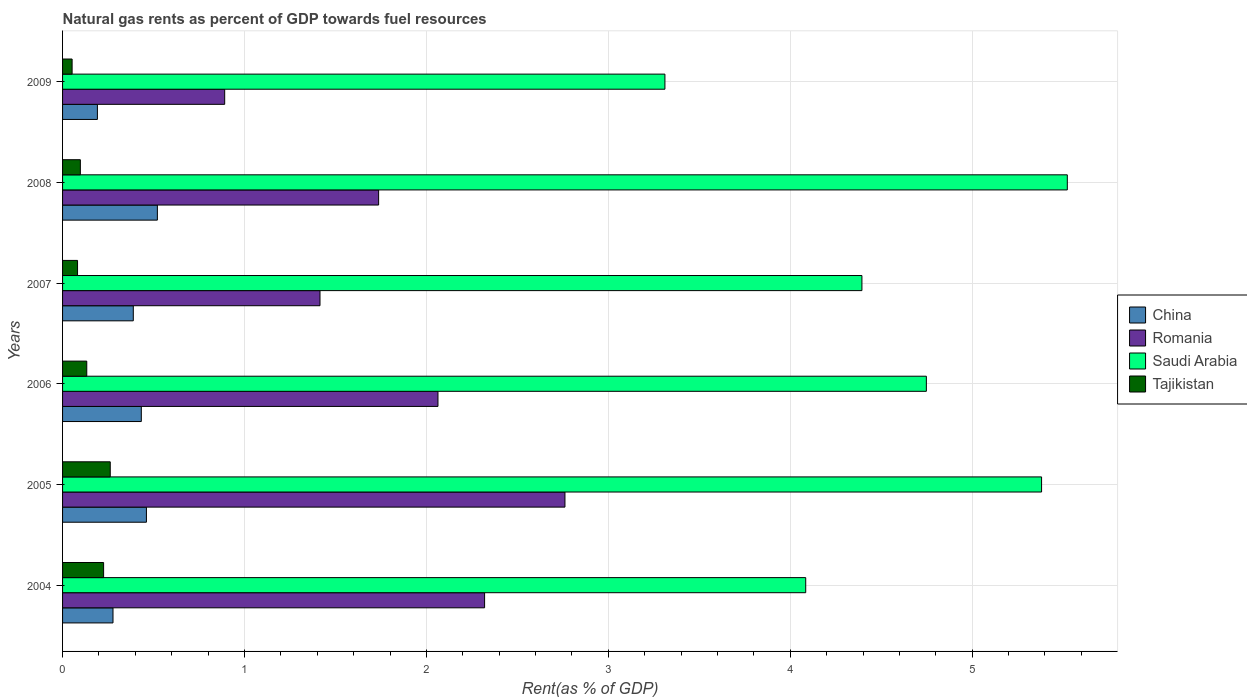How many groups of bars are there?
Make the answer very short. 6. Are the number of bars per tick equal to the number of legend labels?
Offer a very short reply. Yes. Are the number of bars on each tick of the Y-axis equal?
Your response must be concise. Yes. How many bars are there on the 3rd tick from the bottom?
Give a very brief answer. 4. In how many cases, is the number of bars for a given year not equal to the number of legend labels?
Provide a succinct answer. 0. What is the matural gas rent in Tajikistan in 2007?
Make the answer very short. 0.08. Across all years, what is the maximum matural gas rent in China?
Your answer should be compact. 0.52. Across all years, what is the minimum matural gas rent in Saudi Arabia?
Make the answer very short. 3.31. In which year was the matural gas rent in Tajikistan maximum?
Provide a succinct answer. 2005. What is the total matural gas rent in China in the graph?
Offer a terse response. 2.27. What is the difference between the matural gas rent in Saudi Arabia in 2005 and that in 2009?
Ensure brevity in your answer.  2.07. What is the difference between the matural gas rent in Romania in 2006 and the matural gas rent in Tajikistan in 2007?
Provide a short and direct response. 1.98. What is the average matural gas rent in Romania per year?
Give a very brief answer. 1.86. In the year 2007, what is the difference between the matural gas rent in Romania and matural gas rent in Tajikistan?
Provide a succinct answer. 1.33. In how many years, is the matural gas rent in Tajikistan greater than 3 %?
Provide a succinct answer. 0. What is the ratio of the matural gas rent in Saudi Arabia in 2004 to that in 2008?
Offer a very short reply. 0.74. Is the matural gas rent in Romania in 2006 less than that in 2008?
Make the answer very short. No. Is the difference between the matural gas rent in Romania in 2004 and 2008 greater than the difference between the matural gas rent in Tajikistan in 2004 and 2008?
Provide a succinct answer. Yes. What is the difference between the highest and the second highest matural gas rent in Saudi Arabia?
Your answer should be very brief. 0.14. What is the difference between the highest and the lowest matural gas rent in China?
Make the answer very short. 0.33. In how many years, is the matural gas rent in Tajikistan greater than the average matural gas rent in Tajikistan taken over all years?
Make the answer very short. 2. Is it the case that in every year, the sum of the matural gas rent in Tajikistan and matural gas rent in Saudi Arabia is greater than the sum of matural gas rent in Romania and matural gas rent in China?
Offer a very short reply. Yes. How many bars are there?
Offer a terse response. 24. Are all the bars in the graph horizontal?
Ensure brevity in your answer.  Yes. How many years are there in the graph?
Your answer should be very brief. 6. What is the difference between two consecutive major ticks on the X-axis?
Ensure brevity in your answer.  1. Are the values on the major ticks of X-axis written in scientific E-notation?
Give a very brief answer. No. Does the graph contain any zero values?
Ensure brevity in your answer.  No. Where does the legend appear in the graph?
Provide a short and direct response. Center right. How many legend labels are there?
Your answer should be compact. 4. How are the legend labels stacked?
Offer a terse response. Vertical. What is the title of the graph?
Ensure brevity in your answer.  Natural gas rents as percent of GDP towards fuel resources. What is the label or title of the X-axis?
Offer a very short reply. Rent(as % of GDP). What is the label or title of the Y-axis?
Make the answer very short. Years. What is the Rent(as % of GDP) in China in 2004?
Provide a short and direct response. 0.28. What is the Rent(as % of GDP) in Romania in 2004?
Keep it short and to the point. 2.32. What is the Rent(as % of GDP) in Saudi Arabia in 2004?
Your answer should be compact. 4.09. What is the Rent(as % of GDP) in Tajikistan in 2004?
Provide a succinct answer. 0.23. What is the Rent(as % of GDP) of China in 2005?
Make the answer very short. 0.46. What is the Rent(as % of GDP) of Romania in 2005?
Your answer should be compact. 2.76. What is the Rent(as % of GDP) of Saudi Arabia in 2005?
Provide a succinct answer. 5.38. What is the Rent(as % of GDP) of Tajikistan in 2005?
Provide a succinct answer. 0.26. What is the Rent(as % of GDP) in China in 2006?
Your response must be concise. 0.43. What is the Rent(as % of GDP) in Romania in 2006?
Give a very brief answer. 2.06. What is the Rent(as % of GDP) of Saudi Arabia in 2006?
Your response must be concise. 4.75. What is the Rent(as % of GDP) in Tajikistan in 2006?
Ensure brevity in your answer.  0.13. What is the Rent(as % of GDP) in China in 2007?
Ensure brevity in your answer.  0.39. What is the Rent(as % of GDP) in Romania in 2007?
Offer a terse response. 1.42. What is the Rent(as % of GDP) in Saudi Arabia in 2007?
Keep it short and to the point. 4.39. What is the Rent(as % of GDP) in Tajikistan in 2007?
Provide a succinct answer. 0.08. What is the Rent(as % of GDP) of China in 2008?
Your answer should be compact. 0.52. What is the Rent(as % of GDP) in Romania in 2008?
Your answer should be very brief. 1.74. What is the Rent(as % of GDP) in Saudi Arabia in 2008?
Your answer should be very brief. 5.52. What is the Rent(as % of GDP) in Tajikistan in 2008?
Your answer should be compact. 0.1. What is the Rent(as % of GDP) in China in 2009?
Provide a succinct answer. 0.19. What is the Rent(as % of GDP) of Romania in 2009?
Provide a succinct answer. 0.89. What is the Rent(as % of GDP) in Saudi Arabia in 2009?
Your answer should be very brief. 3.31. What is the Rent(as % of GDP) in Tajikistan in 2009?
Offer a terse response. 0.05. Across all years, what is the maximum Rent(as % of GDP) in China?
Your response must be concise. 0.52. Across all years, what is the maximum Rent(as % of GDP) of Romania?
Your answer should be compact. 2.76. Across all years, what is the maximum Rent(as % of GDP) in Saudi Arabia?
Your response must be concise. 5.52. Across all years, what is the maximum Rent(as % of GDP) of Tajikistan?
Keep it short and to the point. 0.26. Across all years, what is the minimum Rent(as % of GDP) in China?
Give a very brief answer. 0.19. Across all years, what is the minimum Rent(as % of GDP) of Romania?
Give a very brief answer. 0.89. Across all years, what is the minimum Rent(as % of GDP) of Saudi Arabia?
Provide a short and direct response. 3.31. Across all years, what is the minimum Rent(as % of GDP) of Tajikistan?
Offer a very short reply. 0.05. What is the total Rent(as % of GDP) in China in the graph?
Offer a terse response. 2.27. What is the total Rent(as % of GDP) in Romania in the graph?
Ensure brevity in your answer.  11.19. What is the total Rent(as % of GDP) in Saudi Arabia in the graph?
Give a very brief answer. 27.44. What is the total Rent(as % of GDP) of Tajikistan in the graph?
Make the answer very short. 0.85. What is the difference between the Rent(as % of GDP) in China in 2004 and that in 2005?
Offer a terse response. -0.18. What is the difference between the Rent(as % of GDP) of Romania in 2004 and that in 2005?
Give a very brief answer. -0.44. What is the difference between the Rent(as % of GDP) in Saudi Arabia in 2004 and that in 2005?
Keep it short and to the point. -1.3. What is the difference between the Rent(as % of GDP) of Tajikistan in 2004 and that in 2005?
Your response must be concise. -0.04. What is the difference between the Rent(as % of GDP) in China in 2004 and that in 2006?
Provide a succinct answer. -0.16. What is the difference between the Rent(as % of GDP) of Romania in 2004 and that in 2006?
Provide a short and direct response. 0.26. What is the difference between the Rent(as % of GDP) in Saudi Arabia in 2004 and that in 2006?
Offer a terse response. -0.66. What is the difference between the Rent(as % of GDP) in Tajikistan in 2004 and that in 2006?
Your answer should be compact. 0.09. What is the difference between the Rent(as % of GDP) of China in 2004 and that in 2007?
Your answer should be compact. -0.11. What is the difference between the Rent(as % of GDP) in Romania in 2004 and that in 2007?
Your response must be concise. 0.9. What is the difference between the Rent(as % of GDP) in Saudi Arabia in 2004 and that in 2007?
Ensure brevity in your answer.  -0.31. What is the difference between the Rent(as % of GDP) in Tajikistan in 2004 and that in 2007?
Give a very brief answer. 0.14. What is the difference between the Rent(as % of GDP) in China in 2004 and that in 2008?
Your response must be concise. -0.24. What is the difference between the Rent(as % of GDP) of Romania in 2004 and that in 2008?
Your response must be concise. 0.58. What is the difference between the Rent(as % of GDP) of Saudi Arabia in 2004 and that in 2008?
Provide a succinct answer. -1.44. What is the difference between the Rent(as % of GDP) in Tajikistan in 2004 and that in 2008?
Give a very brief answer. 0.13. What is the difference between the Rent(as % of GDP) of China in 2004 and that in 2009?
Give a very brief answer. 0.09. What is the difference between the Rent(as % of GDP) of Romania in 2004 and that in 2009?
Your answer should be compact. 1.43. What is the difference between the Rent(as % of GDP) in Saudi Arabia in 2004 and that in 2009?
Give a very brief answer. 0.77. What is the difference between the Rent(as % of GDP) of Tajikistan in 2004 and that in 2009?
Offer a terse response. 0.17. What is the difference between the Rent(as % of GDP) of China in 2005 and that in 2006?
Make the answer very short. 0.03. What is the difference between the Rent(as % of GDP) of Romania in 2005 and that in 2006?
Offer a terse response. 0.7. What is the difference between the Rent(as % of GDP) in Saudi Arabia in 2005 and that in 2006?
Provide a succinct answer. 0.63. What is the difference between the Rent(as % of GDP) of Tajikistan in 2005 and that in 2006?
Give a very brief answer. 0.13. What is the difference between the Rent(as % of GDP) of China in 2005 and that in 2007?
Offer a terse response. 0.07. What is the difference between the Rent(as % of GDP) of Romania in 2005 and that in 2007?
Provide a succinct answer. 1.35. What is the difference between the Rent(as % of GDP) in Saudi Arabia in 2005 and that in 2007?
Your answer should be very brief. 0.99. What is the difference between the Rent(as % of GDP) in Tajikistan in 2005 and that in 2007?
Make the answer very short. 0.18. What is the difference between the Rent(as % of GDP) of China in 2005 and that in 2008?
Your answer should be very brief. -0.06. What is the difference between the Rent(as % of GDP) of Romania in 2005 and that in 2008?
Keep it short and to the point. 1.02. What is the difference between the Rent(as % of GDP) of Saudi Arabia in 2005 and that in 2008?
Make the answer very short. -0.14. What is the difference between the Rent(as % of GDP) in Tajikistan in 2005 and that in 2008?
Ensure brevity in your answer.  0.16. What is the difference between the Rent(as % of GDP) in China in 2005 and that in 2009?
Provide a succinct answer. 0.27. What is the difference between the Rent(as % of GDP) of Romania in 2005 and that in 2009?
Provide a succinct answer. 1.87. What is the difference between the Rent(as % of GDP) of Saudi Arabia in 2005 and that in 2009?
Ensure brevity in your answer.  2.07. What is the difference between the Rent(as % of GDP) in Tajikistan in 2005 and that in 2009?
Provide a succinct answer. 0.21. What is the difference between the Rent(as % of GDP) in China in 2006 and that in 2007?
Your response must be concise. 0.04. What is the difference between the Rent(as % of GDP) of Romania in 2006 and that in 2007?
Provide a short and direct response. 0.65. What is the difference between the Rent(as % of GDP) of Saudi Arabia in 2006 and that in 2007?
Your answer should be compact. 0.35. What is the difference between the Rent(as % of GDP) of Tajikistan in 2006 and that in 2007?
Give a very brief answer. 0.05. What is the difference between the Rent(as % of GDP) in China in 2006 and that in 2008?
Your response must be concise. -0.09. What is the difference between the Rent(as % of GDP) of Romania in 2006 and that in 2008?
Make the answer very short. 0.33. What is the difference between the Rent(as % of GDP) in Saudi Arabia in 2006 and that in 2008?
Keep it short and to the point. -0.77. What is the difference between the Rent(as % of GDP) in Tajikistan in 2006 and that in 2008?
Your response must be concise. 0.04. What is the difference between the Rent(as % of GDP) of China in 2006 and that in 2009?
Offer a very short reply. 0.24. What is the difference between the Rent(as % of GDP) in Romania in 2006 and that in 2009?
Make the answer very short. 1.17. What is the difference between the Rent(as % of GDP) of Saudi Arabia in 2006 and that in 2009?
Offer a terse response. 1.44. What is the difference between the Rent(as % of GDP) in Tajikistan in 2006 and that in 2009?
Your response must be concise. 0.08. What is the difference between the Rent(as % of GDP) in China in 2007 and that in 2008?
Your response must be concise. -0.13. What is the difference between the Rent(as % of GDP) of Romania in 2007 and that in 2008?
Your answer should be compact. -0.32. What is the difference between the Rent(as % of GDP) of Saudi Arabia in 2007 and that in 2008?
Your response must be concise. -1.13. What is the difference between the Rent(as % of GDP) in Tajikistan in 2007 and that in 2008?
Give a very brief answer. -0.02. What is the difference between the Rent(as % of GDP) of China in 2007 and that in 2009?
Provide a short and direct response. 0.2. What is the difference between the Rent(as % of GDP) in Romania in 2007 and that in 2009?
Offer a very short reply. 0.52. What is the difference between the Rent(as % of GDP) of Saudi Arabia in 2007 and that in 2009?
Provide a succinct answer. 1.08. What is the difference between the Rent(as % of GDP) in Tajikistan in 2007 and that in 2009?
Offer a very short reply. 0.03. What is the difference between the Rent(as % of GDP) of China in 2008 and that in 2009?
Keep it short and to the point. 0.33. What is the difference between the Rent(as % of GDP) of Romania in 2008 and that in 2009?
Your answer should be very brief. 0.85. What is the difference between the Rent(as % of GDP) of Saudi Arabia in 2008 and that in 2009?
Offer a very short reply. 2.21. What is the difference between the Rent(as % of GDP) in Tajikistan in 2008 and that in 2009?
Make the answer very short. 0.05. What is the difference between the Rent(as % of GDP) in China in 2004 and the Rent(as % of GDP) in Romania in 2005?
Your answer should be compact. -2.48. What is the difference between the Rent(as % of GDP) in China in 2004 and the Rent(as % of GDP) in Saudi Arabia in 2005?
Your response must be concise. -5.1. What is the difference between the Rent(as % of GDP) in China in 2004 and the Rent(as % of GDP) in Tajikistan in 2005?
Provide a succinct answer. 0.02. What is the difference between the Rent(as % of GDP) of Romania in 2004 and the Rent(as % of GDP) of Saudi Arabia in 2005?
Your answer should be very brief. -3.06. What is the difference between the Rent(as % of GDP) of Romania in 2004 and the Rent(as % of GDP) of Tajikistan in 2005?
Your answer should be compact. 2.06. What is the difference between the Rent(as % of GDP) in Saudi Arabia in 2004 and the Rent(as % of GDP) in Tajikistan in 2005?
Make the answer very short. 3.82. What is the difference between the Rent(as % of GDP) in China in 2004 and the Rent(as % of GDP) in Romania in 2006?
Keep it short and to the point. -1.79. What is the difference between the Rent(as % of GDP) in China in 2004 and the Rent(as % of GDP) in Saudi Arabia in 2006?
Ensure brevity in your answer.  -4.47. What is the difference between the Rent(as % of GDP) in China in 2004 and the Rent(as % of GDP) in Tajikistan in 2006?
Offer a very short reply. 0.14. What is the difference between the Rent(as % of GDP) of Romania in 2004 and the Rent(as % of GDP) of Saudi Arabia in 2006?
Your answer should be very brief. -2.43. What is the difference between the Rent(as % of GDP) in Romania in 2004 and the Rent(as % of GDP) in Tajikistan in 2006?
Your answer should be very brief. 2.19. What is the difference between the Rent(as % of GDP) of Saudi Arabia in 2004 and the Rent(as % of GDP) of Tajikistan in 2006?
Offer a terse response. 3.95. What is the difference between the Rent(as % of GDP) of China in 2004 and the Rent(as % of GDP) of Romania in 2007?
Make the answer very short. -1.14. What is the difference between the Rent(as % of GDP) of China in 2004 and the Rent(as % of GDP) of Saudi Arabia in 2007?
Offer a terse response. -4.12. What is the difference between the Rent(as % of GDP) of China in 2004 and the Rent(as % of GDP) of Tajikistan in 2007?
Offer a very short reply. 0.19. What is the difference between the Rent(as % of GDP) in Romania in 2004 and the Rent(as % of GDP) in Saudi Arabia in 2007?
Give a very brief answer. -2.07. What is the difference between the Rent(as % of GDP) in Romania in 2004 and the Rent(as % of GDP) in Tajikistan in 2007?
Provide a succinct answer. 2.24. What is the difference between the Rent(as % of GDP) in Saudi Arabia in 2004 and the Rent(as % of GDP) in Tajikistan in 2007?
Provide a short and direct response. 4. What is the difference between the Rent(as % of GDP) of China in 2004 and the Rent(as % of GDP) of Romania in 2008?
Give a very brief answer. -1.46. What is the difference between the Rent(as % of GDP) in China in 2004 and the Rent(as % of GDP) in Saudi Arabia in 2008?
Your response must be concise. -5.25. What is the difference between the Rent(as % of GDP) of China in 2004 and the Rent(as % of GDP) of Tajikistan in 2008?
Provide a succinct answer. 0.18. What is the difference between the Rent(as % of GDP) in Romania in 2004 and the Rent(as % of GDP) in Saudi Arabia in 2008?
Keep it short and to the point. -3.2. What is the difference between the Rent(as % of GDP) in Romania in 2004 and the Rent(as % of GDP) in Tajikistan in 2008?
Give a very brief answer. 2.22. What is the difference between the Rent(as % of GDP) in Saudi Arabia in 2004 and the Rent(as % of GDP) in Tajikistan in 2008?
Your response must be concise. 3.99. What is the difference between the Rent(as % of GDP) in China in 2004 and the Rent(as % of GDP) in Romania in 2009?
Give a very brief answer. -0.61. What is the difference between the Rent(as % of GDP) of China in 2004 and the Rent(as % of GDP) of Saudi Arabia in 2009?
Provide a succinct answer. -3.03. What is the difference between the Rent(as % of GDP) in China in 2004 and the Rent(as % of GDP) in Tajikistan in 2009?
Offer a very short reply. 0.22. What is the difference between the Rent(as % of GDP) in Romania in 2004 and the Rent(as % of GDP) in Saudi Arabia in 2009?
Your answer should be very brief. -0.99. What is the difference between the Rent(as % of GDP) in Romania in 2004 and the Rent(as % of GDP) in Tajikistan in 2009?
Ensure brevity in your answer.  2.27. What is the difference between the Rent(as % of GDP) of Saudi Arabia in 2004 and the Rent(as % of GDP) of Tajikistan in 2009?
Offer a terse response. 4.03. What is the difference between the Rent(as % of GDP) of China in 2005 and the Rent(as % of GDP) of Romania in 2006?
Make the answer very short. -1.6. What is the difference between the Rent(as % of GDP) in China in 2005 and the Rent(as % of GDP) in Saudi Arabia in 2006?
Offer a very short reply. -4.29. What is the difference between the Rent(as % of GDP) in China in 2005 and the Rent(as % of GDP) in Tajikistan in 2006?
Your answer should be compact. 0.33. What is the difference between the Rent(as % of GDP) in Romania in 2005 and the Rent(as % of GDP) in Saudi Arabia in 2006?
Your response must be concise. -1.99. What is the difference between the Rent(as % of GDP) in Romania in 2005 and the Rent(as % of GDP) in Tajikistan in 2006?
Offer a terse response. 2.63. What is the difference between the Rent(as % of GDP) of Saudi Arabia in 2005 and the Rent(as % of GDP) of Tajikistan in 2006?
Provide a short and direct response. 5.25. What is the difference between the Rent(as % of GDP) in China in 2005 and the Rent(as % of GDP) in Romania in 2007?
Make the answer very short. -0.95. What is the difference between the Rent(as % of GDP) in China in 2005 and the Rent(as % of GDP) in Saudi Arabia in 2007?
Make the answer very short. -3.93. What is the difference between the Rent(as % of GDP) in China in 2005 and the Rent(as % of GDP) in Tajikistan in 2007?
Offer a very short reply. 0.38. What is the difference between the Rent(as % of GDP) in Romania in 2005 and the Rent(as % of GDP) in Saudi Arabia in 2007?
Offer a very short reply. -1.63. What is the difference between the Rent(as % of GDP) of Romania in 2005 and the Rent(as % of GDP) of Tajikistan in 2007?
Your answer should be compact. 2.68. What is the difference between the Rent(as % of GDP) of Saudi Arabia in 2005 and the Rent(as % of GDP) of Tajikistan in 2007?
Offer a terse response. 5.3. What is the difference between the Rent(as % of GDP) of China in 2005 and the Rent(as % of GDP) of Romania in 2008?
Your response must be concise. -1.28. What is the difference between the Rent(as % of GDP) of China in 2005 and the Rent(as % of GDP) of Saudi Arabia in 2008?
Your response must be concise. -5.06. What is the difference between the Rent(as % of GDP) of China in 2005 and the Rent(as % of GDP) of Tajikistan in 2008?
Provide a succinct answer. 0.36. What is the difference between the Rent(as % of GDP) in Romania in 2005 and the Rent(as % of GDP) in Saudi Arabia in 2008?
Provide a short and direct response. -2.76. What is the difference between the Rent(as % of GDP) in Romania in 2005 and the Rent(as % of GDP) in Tajikistan in 2008?
Your response must be concise. 2.66. What is the difference between the Rent(as % of GDP) in Saudi Arabia in 2005 and the Rent(as % of GDP) in Tajikistan in 2008?
Make the answer very short. 5.28. What is the difference between the Rent(as % of GDP) of China in 2005 and the Rent(as % of GDP) of Romania in 2009?
Ensure brevity in your answer.  -0.43. What is the difference between the Rent(as % of GDP) of China in 2005 and the Rent(as % of GDP) of Saudi Arabia in 2009?
Give a very brief answer. -2.85. What is the difference between the Rent(as % of GDP) of China in 2005 and the Rent(as % of GDP) of Tajikistan in 2009?
Offer a very short reply. 0.41. What is the difference between the Rent(as % of GDP) of Romania in 2005 and the Rent(as % of GDP) of Saudi Arabia in 2009?
Provide a succinct answer. -0.55. What is the difference between the Rent(as % of GDP) of Romania in 2005 and the Rent(as % of GDP) of Tajikistan in 2009?
Offer a very short reply. 2.71. What is the difference between the Rent(as % of GDP) in Saudi Arabia in 2005 and the Rent(as % of GDP) in Tajikistan in 2009?
Your answer should be compact. 5.33. What is the difference between the Rent(as % of GDP) in China in 2006 and the Rent(as % of GDP) in Romania in 2007?
Give a very brief answer. -0.98. What is the difference between the Rent(as % of GDP) in China in 2006 and the Rent(as % of GDP) in Saudi Arabia in 2007?
Keep it short and to the point. -3.96. What is the difference between the Rent(as % of GDP) of China in 2006 and the Rent(as % of GDP) of Tajikistan in 2007?
Give a very brief answer. 0.35. What is the difference between the Rent(as % of GDP) of Romania in 2006 and the Rent(as % of GDP) of Saudi Arabia in 2007?
Provide a short and direct response. -2.33. What is the difference between the Rent(as % of GDP) in Romania in 2006 and the Rent(as % of GDP) in Tajikistan in 2007?
Provide a succinct answer. 1.98. What is the difference between the Rent(as % of GDP) of Saudi Arabia in 2006 and the Rent(as % of GDP) of Tajikistan in 2007?
Provide a short and direct response. 4.67. What is the difference between the Rent(as % of GDP) of China in 2006 and the Rent(as % of GDP) of Romania in 2008?
Your answer should be very brief. -1.3. What is the difference between the Rent(as % of GDP) in China in 2006 and the Rent(as % of GDP) in Saudi Arabia in 2008?
Ensure brevity in your answer.  -5.09. What is the difference between the Rent(as % of GDP) of China in 2006 and the Rent(as % of GDP) of Tajikistan in 2008?
Provide a succinct answer. 0.34. What is the difference between the Rent(as % of GDP) of Romania in 2006 and the Rent(as % of GDP) of Saudi Arabia in 2008?
Keep it short and to the point. -3.46. What is the difference between the Rent(as % of GDP) in Romania in 2006 and the Rent(as % of GDP) in Tajikistan in 2008?
Make the answer very short. 1.97. What is the difference between the Rent(as % of GDP) of Saudi Arabia in 2006 and the Rent(as % of GDP) of Tajikistan in 2008?
Ensure brevity in your answer.  4.65. What is the difference between the Rent(as % of GDP) in China in 2006 and the Rent(as % of GDP) in Romania in 2009?
Your answer should be compact. -0.46. What is the difference between the Rent(as % of GDP) of China in 2006 and the Rent(as % of GDP) of Saudi Arabia in 2009?
Offer a terse response. -2.88. What is the difference between the Rent(as % of GDP) of China in 2006 and the Rent(as % of GDP) of Tajikistan in 2009?
Offer a very short reply. 0.38. What is the difference between the Rent(as % of GDP) of Romania in 2006 and the Rent(as % of GDP) of Saudi Arabia in 2009?
Your answer should be compact. -1.25. What is the difference between the Rent(as % of GDP) of Romania in 2006 and the Rent(as % of GDP) of Tajikistan in 2009?
Give a very brief answer. 2.01. What is the difference between the Rent(as % of GDP) of Saudi Arabia in 2006 and the Rent(as % of GDP) of Tajikistan in 2009?
Offer a terse response. 4.7. What is the difference between the Rent(as % of GDP) of China in 2007 and the Rent(as % of GDP) of Romania in 2008?
Your answer should be very brief. -1.35. What is the difference between the Rent(as % of GDP) in China in 2007 and the Rent(as % of GDP) in Saudi Arabia in 2008?
Your answer should be very brief. -5.13. What is the difference between the Rent(as % of GDP) of China in 2007 and the Rent(as % of GDP) of Tajikistan in 2008?
Keep it short and to the point. 0.29. What is the difference between the Rent(as % of GDP) in Romania in 2007 and the Rent(as % of GDP) in Saudi Arabia in 2008?
Offer a very short reply. -4.11. What is the difference between the Rent(as % of GDP) in Romania in 2007 and the Rent(as % of GDP) in Tajikistan in 2008?
Your response must be concise. 1.32. What is the difference between the Rent(as % of GDP) in Saudi Arabia in 2007 and the Rent(as % of GDP) in Tajikistan in 2008?
Your response must be concise. 4.3. What is the difference between the Rent(as % of GDP) of China in 2007 and the Rent(as % of GDP) of Romania in 2009?
Keep it short and to the point. -0.5. What is the difference between the Rent(as % of GDP) in China in 2007 and the Rent(as % of GDP) in Saudi Arabia in 2009?
Your answer should be compact. -2.92. What is the difference between the Rent(as % of GDP) in China in 2007 and the Rent(as % of GDP) in Tajikistan in 2009?
Provide a short and direct response. 0.34. What is the difference between the Rent(as % of GDP) of Romania in 2007 and the Rent(as % of GDP) of Saudi Arabia in 2009?
Your answer should be compact. -1.9. What is the difference between the Rent(as % of GDP) in Romania in 2007 and the Rent(as % of GDP) in Tajikistan in 2009?
Provide a succinct answer. 1.36. What is the difference between the Rent(as % of GDP) of Saudi Arabia in 2007 and the Rent(as % of GDP) of Tajikistan in 2009?
Make the answer very short. 4.34. What is the difference between the Rent(as % of GDP) of China in 2008 and the Rent(as % of GDP) of Romania in 2009?
Your answer should be compact. -0.37. What is the difference between the Rent(as % of GDP) in China in 2008 and the Rent(as % of GDP) in Saudi Arabia in 2009?
Give a very brief answer. -2.79. What is the difference between the Rent(as % of GDP) of China in 2008 and the Rent(as % of GDP) of Tajikistan in 2009?
Ensure brevity in your answer.  0.47. What is the difference between the Rent(as % of GDP) of Romania in 2008 and the Rent(as % of GDP) of Saudi Arabia in 2009?
Your answer should be compact. -1.57. What is the difference between the Rent(as % of GDP) of Romania in 2008 and the Rent(as % of GDP) of Tajikistan in 2009?
Make the answer very short. 1.68. What is the difference between the Rent(as % of GDP) of Saudi Arabia in 2008 and the Rent(as % of GDP) of Tajikistan in 2009?
Your response must be concise. 5.47. What is the average Rent(as % of GDP) in China per year?
Provide a short and direct response. 0.38. What is the average Rent(as % of GDP) of Romania per year?
Ensure brevity in your answer.  1.86. What is the average Rent(as % of GDP) in Saudi Arabia per year?
Offer a terse response. 4.57. What is the average Rent(as % of GDP) in Tajikistan per year?
Offer a very short reply. 0.14. In the year 2004, what is the difference between the Rent(as % of GDP) in China and Rent(as % of GDP) in Romania?
Your answer should be compact. -2.04. In the year 2004, what is the difference between the Rent(as % of GDP) of China and Rent(as % of GDP) of Saudi Arabia?
Your response must be concise. -3.81. In the year 2004, what is the difference between the Rent(as % of GDP) in China and Rent(as % of GDP) in Tajikistan?
Your answer should be very brief. 0.05. In the year 2004, what is the difference between the Rent(as % of GDP) in Romania and Rent(as % of GDP) in Saudi Arabia?
Provide a succinct answer. -1.77. In the year 2004, what is the difference between the Rent(as % of GDP) of Romania and Rent(as % of GDP) of Tajikistan?
Your response must be concise. 2.09. In the year 2004, what is the difference between the Rent(as % of GDP) of Saudi Arabia and Rent(as % of GDP) of Tajikistan?
Provide a short and direct response. 3.86. In the year 2005, what is the difference between the Rent(as % of GDP) in China and Rent(as % of GDP) in Romania?
Offer a terse response. -2.3. In the year 2005, what is the difference between the Rent(as % of GDP) of China and Rent(as % of GDP) of Saudi Arabia?
Provide a succinct answer. -4.92. In the year 2005, what is the difference between the Rent(as % of GDP) in China and Rent(as % of GDP) in Tajikistan?
Offer a very short reply. 0.2. In the year 2005, what is the difference between the Rent(as % of GDP) in Romania and Rent(as % of GDP) in Saudi Arabia?
Provide a short and direct response. -2.62. In the year 2005, what is the difference between the Rent(as % of GDP) of Romania and Rent(as % of GDP) of Tajikistan?
Your response must be concise. 2.5. In the year 2005, what is the difference between the Rent(as % of GDP) in Saudi Arabia and Rent(as % of GDP) in Tajikistan?
Your answer should be compact. 5.12. In the year 2006, what is the difference between the Rent(as % of GDP) of China and Rent(as % of GDP) of Romania?
Your answer should be very brief. -1.63. In the year 2006, what is the difference between the Rent(as % of GDP) in China and Rent(as % of GDP) in Saudi Arabia?
Offer a terse response. -4.32. In the year 2006, what is the difference between the Rent(as % of GDP) of China and Rent(as % of GDP) of Tajikistan?
Your answer should be very brief. 0.3. In the year 2006, what is the difference between the Rent(as % of GDP) in Romania and Rent(as % of GDP) in Saudi Arabia?
Provide a short and direct response. -2.68. In the year 2006, what is the difference between the Rent(as % of GDP) of Romania and Rent(as % of GDP) of Tajikistan?
Ensure brevity in your answer.  1.93. In the year 2006, what is the difference between the Rent(as % of GDP) in Saudi Arabia and Rent(as % of GDP) in Tajikistan?
Provide a succinct answer. 4.62. In the year 2007, what is the difference between the Rent(as % of GDP) of China and Rent(as % of GDP) of Romania?
Make the answer very short. -1.03. In the year 2007, what is the difference between the Rent(as % of GDP) of China and Rent(as % of GDP) of Saudi Arabia?
Offer a terse response. -4.01. In the year 2007, what is the difference between the Rent(as % of GDP) in China and Rent(as % of GDP) in Tajikistan?
Provide a short and direct response. 0.31. In the year 2007, what is the difference between the Rent(as % of GDP) in Romania and Rent(as % of GDP) in Saudi Arabia?
Ensure brevity in your answer.  -2.98. In the year 2007, what is the difference between the Rent(as % of GDP) of Romania and Rent(as % of GDP) of Tajikistan?
Ensure brevity in your answer.  1.33. In the year 2007, what is the difference between the Rent(as % of GDP) of Saudi Arabia and Rent(as % of GDP) of Tajikistan?
Your answer should be very brief. 4.31. In the year 2008, what is the difference between the Rent(as % of GDP) of China and Rent(as % of GDP) of Romania?
Ensure brevity in your answer.  -1.22. In the year 2008, what is the difference between the Rent(as % of GDP) in China and Rent(as % of GDP) in Saudi Arabia?
Your answer should be compact. -5. In the year 2008, what is the difference between the Rent(as % of GDP) of China and Rent(as % of GDP) of Tajikistan?
Make the answer very short. 0.42. In the year 2008, what is the difference between the Rent(as % of GDP) of Romania and Rent(as % of GDP) of Saudi Arabia?
Make the answer very short. -3.79. In the year 2008, what is the difference between the Rent(as % of GDP) of Romania and Rent(as % of GDP) of Tajikistan?
Your answer should be very brief. 1.64. In the year 2008, what is the difference between the Rent(as % of GDP) of Saudi Arabia and Rent(as % of GDP) of Tajikistan?
Make the answer very short. 5.43. In the year 2009, what is the difference between the Rent(as % of GDP) of China and Rent(as % of GDP) of Romania?
Your response must be concise. -0.7. In the year 2009, what is the difference between the Rent(as % of GDP) in China and Rent(as % of GDP) in Saudi Arabia?
Make the answer very short. -3.12. In the year 2009, what is the difference between the Rent(as % of GDP) of China and Rent(as % of GDP) of Tajikistan?
Your answer should be compact. 0.14. In the year 2009, what is the difference between the Rent(as % of GDP) of Romania and Rent(as % of GDP) of Saudi Arabia?
Give a very brief answer. -2.42. In the year 2009, what is the difference between the Rent(as % of GDP) of Romania and Rent(as % of GDP) of Tajikistan?
Give a very brief answer. 0.84. In the year 2009, what is the difference between the Rent(as % of GDP) of Saudi Arabia and Rent(as % of GDP) of Tajikistan?
Ensure brevity in your answer.  3.26. What is the ratio of the Rent(as % of GDP) in China in 2004 to that in 2005?
Give a very brief answer. 0.6. What is the ratio of the Rent(as % of GDP) of Romania in 2004 to that in 2005?
Provide a succinct answer. 0.84. What is the ratio of the Rent(as % of GDP) of Saudi Arabia in 2004 to that in 2005?
Keep it short and to the point. 0.76. What is the ratio of the Rent(as % of GDP) of Tajikistan in 2004 to that in 2005?
Provide a succinct answer. 0.86. What is the ratio of the Rent(as % of GDP) of China in 2004 to that in 2006?
Provide a short and direct response. 0.64. What is the ratio of the Rent(as % of GDP) in Romania in 2004 to that in 2006?
Your answer should be compact. 1.12. What is the ratio of the Rent(as % of GDP) in Saudi Arabia in 2004 to that in 2006?
Your answer should be very brief. 0.86. What is the ratio of the Rent(as % of GDP) in Tajikistan in 2004 to that in 2006?
Provide a succinct answer. 1.7. What is the ratio of the Rent(as % of GDP) of China in 2004 to that in 2007?
Make the answer very short. 0.71. What is the ratio of the Rent(as % of GDP) in Romania in 2004 to that in 2007?
Keep it short and to the point. 1.64. What is the ratio of the Rent(as % of GDP) in Saudi Arabia in 2004 to that in 2007?
Make the answer very short. 0.93. What is the ratio of the Rent(as % of GDP) of Tajikistan in 2004 to that in 2007?
Offer a very short reply. 2.74. What is the ratio of the Rent(as % of GDP) in China in 2004 to that in 2008?
Ensure brevity in your answer.  0.53. What is the ratio of the Rent(as % of GDP) of Romania in 2004 to that in 2008?
Keep it short and to the point. 1.34. What is the ratio of the Rent(as % of GDP) of Saudi Arabia in 2004 to that in 2008?
Provide a succinct answer. 0.74. What is the ratio of the Rent(as % of GDP) in Tajikistan in 2004 to that in 2008?
Keep it short and to the point. 2.31. What is the ratio of the Rent(as % of GDP) in China in 2004 to that in 2009?
Provide a short and direct response. 1.45. What is the ratio of the Rent(as % of GDP) of Romania in 2004 to that in 2009?
Offer a very short reply. 2.6. What is the ratio of the Rent(as % of GDP) in Saudi Arabia in 2004 to that in 2009?
Provide a short and direct response. 1.23. What is the ratio of the Rent(as % of GDP) in Tajikistan in 2004 to that in 2009?
Provide a succinct answer. 4.3. What is the ratio of the Rent(as % of GDP) in China in 2005 to that in 2006?
Keep it short and to the point. 1.06. What is the ratio of the Rent(as % of GDP) of Romania in 2005 to that in 2006?
Ensure brevity in your answer.  1.34. What is the ratio of the Rent(as % of GDP) in Saudi Arabia in 2005 to that in 2006?
Ensure brevity in your answer.  1.13. What is the ratio of the Rent(as % of GDP) of Tajikistan in 2005 to that in 2006?
Your answer should be very brief. 1.97. What is the ratio of the Rent(as % of GDP) in China in 2005 to that in 2007?
Ensure brevity in your answer.  1.19. What is the ratio of the Rent(as % of GDP) of Romania in 2005 to that in 2007?
Provide a short and direct response. 1.95. What is the ratio of the Rent(as % of GDP) of Saudi Arabia in 2005 to that in 2007?
Make the answer very short. 1.22. What is the ratio of the Rent(as % of GDP) in Tajikistan in 2005 to that in 2007?
Ensure brevity in your answer.  3.18. What is the ratio of the Rent(as % of GDP) in China in 2005 to that in 2008?
Keep it short and to the point. 0.88. What is the ratio of the Rent(as % of GDP) of Romania in 2005 to that in 2008?
Keep it short and to the point. 1.59. What is the ratio of the Rent(as % of GDP) of Saudi Arabia in 2005 to that in 2008?
Ensure brevity in your answer.  0.97. What is the ratio of the Rent(as % of GDP) in Tajikistan in 2005 to that in 2008?
Your response must be concise. 2.68. What is the ratio of the Rent(as % of GDP) in China in 2005 to that in 2009?
Your answer should be compact. 2.41. What is the ratio of the Rent(as % of GDP) of Romania in 2005 to that in 2009?
Provide a short and direct response. 3.1. What is the ratio of the Rent(as % of GDP) in Saudi Arabia in 2005 to that in 2009?
Your answer should be very brief. 1.63. What is the ratio of the Rent(as % of GDP) of Tajikistan in 2005 to that in 2009?
Your answer should be compact. 5. What is the ratio of the Rent(as % of GDP) of China in 2006 to that in 2007?
Offer a very short reply. 1.11. What is the ratio of the Rent(as % of GDP) in Romania in 2006 to that in 2007?
Your answer should be compact. 1.46. What is the ratio of the Rent(as % of GDP) in Saudi Arabia in 2006 to that in 2007?
Your answer should be compact. 1.08. What is the ratio of the Rent(as % of GDP) in Tajikistan in 2006 to that in 2007?
Offer a very short reply. 1.61. What is the ratio of the Rent(as % of GDP) of China in 2006 to that in 2008?
Provide a short and direct response. 0.83. What is the ratio of the Rent(as % of GDP) in Romania in 2006 to that in 2008?
Your response must be concise. 1.19. What is the ratio of the Rent(as % of GDP) in Saudi Arabia in 2006 to that in 2008?
Your answer should be compact. 0.86. What is the ratio of the Rent(as % of GDP) in Tajikistan in 2006 to that in 2008?
Ensure brevity in your answer.  1.36. What is the ratio of the Rent(as % of GDP) in China in 2006 to that in 2009?
Offer a terse response. 2.26. What is the ratio of the Rent(as % of GDP) of Romania in 2006 to that in 2009?
Ensure brevity in your answer.  2.32. What is the ratio of the Rent(as % of GDP) in Saudi Arabia in 2006 to that in 2009?
Your answer should be compact. 1.43. What is the ratio of the Rent(as % of GDP) of Tajikistan in 2006 to that in 2009?
Give a very brief answer. 2.54. What is the ratio of the Rent(as % of GDP) of China in 2007 to that in 2008?
Your answer should be very brief. 0.75. What is the ratio of the Rent(as % of GDP) of Romania in 2007 to that in 2008?
Your response must be concise. 0.81. What is the ratio of the Rent(as % of GDP) of Saudi Arabia in 2007 to that in 2008?
Your response must be concise. 0.8. What is the ratio of the Rent(as % of GDP) in Tajikistan in 2007 to that in 2008?
Provide a succinct answer. 0.84. What is the ratio of the Rent(as % of GDP) of China in 2007 to that in 2009?
Your answer should be compact. 2.03. What is the ratio of the Rent(as % of GDP) of Romania in 2007 to that in 2009?
Your answer should be very brief. 1.59. What is the ratio of the Rent(as % of GDP) in Saudi Arabia in 2007 to that in 2009?
Your response must be concise. 1.33. What is the ratio of the Rent(as % of GDP) of Tajikistan in 2007 to that in 2009?
Keep it short and to the point. 1.57. What is the ratio of the Rent(as % of GDP) of China in 2008 to that in 2009?
Offer a very short reply. 2.72. What is the ratio of the Rent(as % of GDP) of Romania in 2008 to that in 2009?
Ensure brevity in your answer.  1.95. What is the ratio of the Rent(as % of GDP) in Saudi Arabia in 2008 to that in 2009?
Provide a short and direct response. 1.67. What is the ratio of the Rent(as % of GDP) of Tajikistan in 2008 to that in 2009?
Offer a terse response. 1.86. What is the difference between the highest and the second highest Rent(as % of GDP) in China?
Your answer should be very brief. 0.06. What is the difference between the highest and the second highest Rent(as % of GDP) in Romania?
Offer a very short reply. 0.44. What is the difference between the highest and the second highest Rent(as % of GDP) in Saudi Arabia?
Keep it short and to the point. 0.14. What is the difference between the highest and the second highest Rent(as % of GDP) of Tajikistan?
Offer a terse response. 0.04. What is the difference between the highest and the lowest Rent(as % of GDP) of China?
Your answer should be compact. 0.33. What is the difference between the highest and the lowest Rent(as % of GDP) of Romania?
Your answer should be very brief. 1.87. What is the difference between the highest and the lowest Rent(as % of GDP) of Saudi Arabia?
Provide a succinct answer. 2.21. What is the difference between the highest and the lowest Rent(as % of GDP) in Tajikistan?
Make the answer very short. 0.21. 